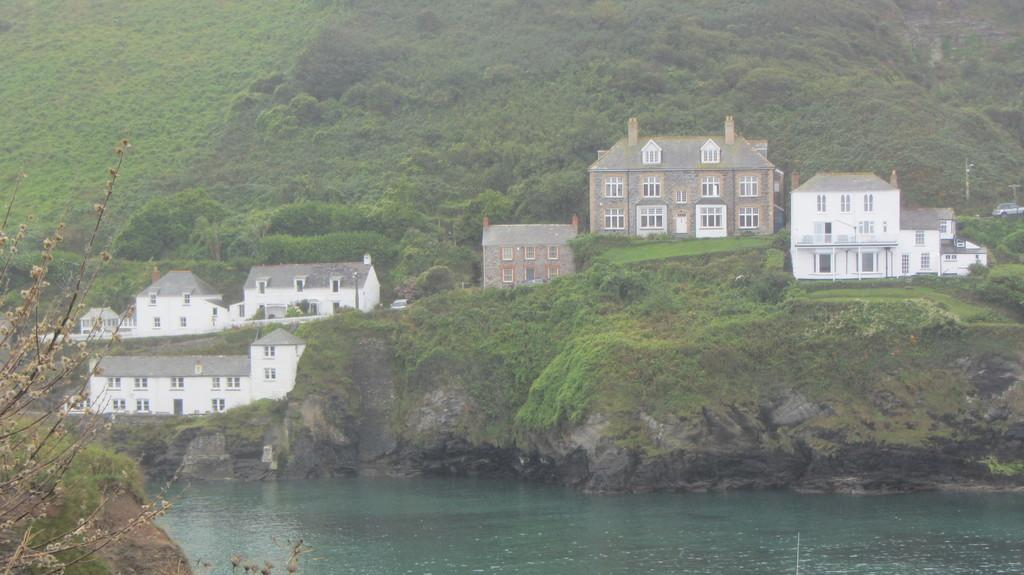What is the primary natural element in the image? There is water in the image. What type of vegetation is present in the image? There is grass in the image. What type of man-made structures can be seen in the image? There are buildings in the image. What mode of transportation is visible in the image? There is a car in the image. What type of zephyr can be seen blowing through the grass in the image? There is no zephyr present in the image; it is a term used to describe a gentle breeze, and there is no indication of wind in the image. 